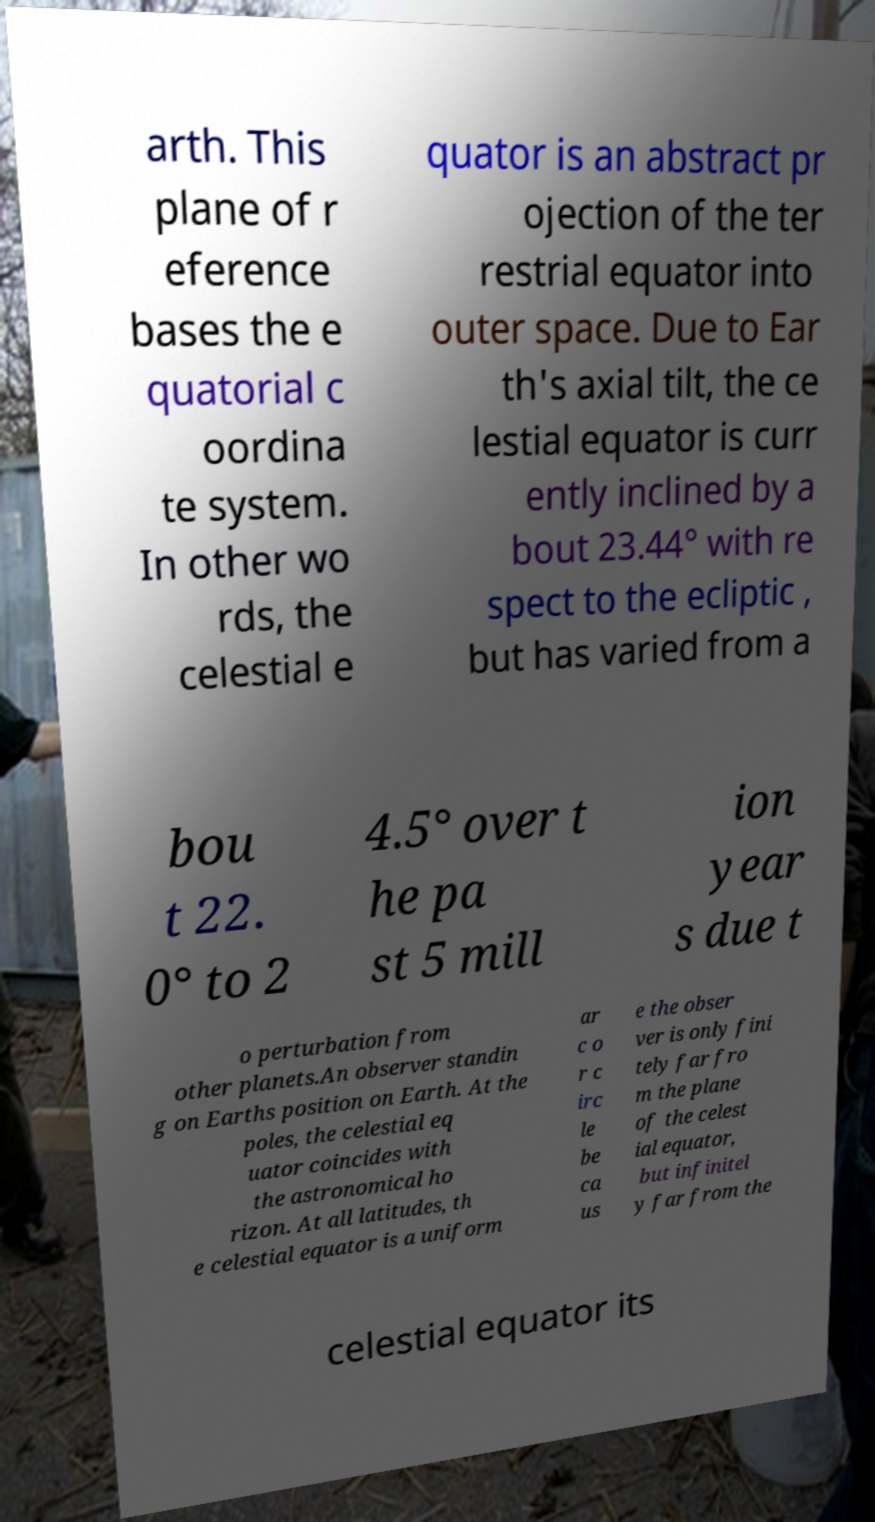For documentation purposes, I need the text within this image transcribed. Could you provide that? arth. This plane of r eference bases the e quatorial c oordina te system. In other wo rds, the celestial e quator is an abstract pr ojection of the ter restrial equator into outer space. Due to Ear th's axial tilt, the ce lestial equator is curr ently inclined by a bout 23.44° with re spect to the ecliptic , but has varied from a bou t 22. 0° to 2 4.5° over t he pa st 5 mill ion year s due t o perturbation from other planets.An observer standin g on Earths position on Earth. At the poles, the celestial eq uator coincides with the astronomical ho rizon. At all latitudes, th e celestial equator is a uniform ar c o r c irc le be ca us e the obser ver is only fini tely far fro m the plane of the celest ial equator, but infinitel y far from the celestial equator its 